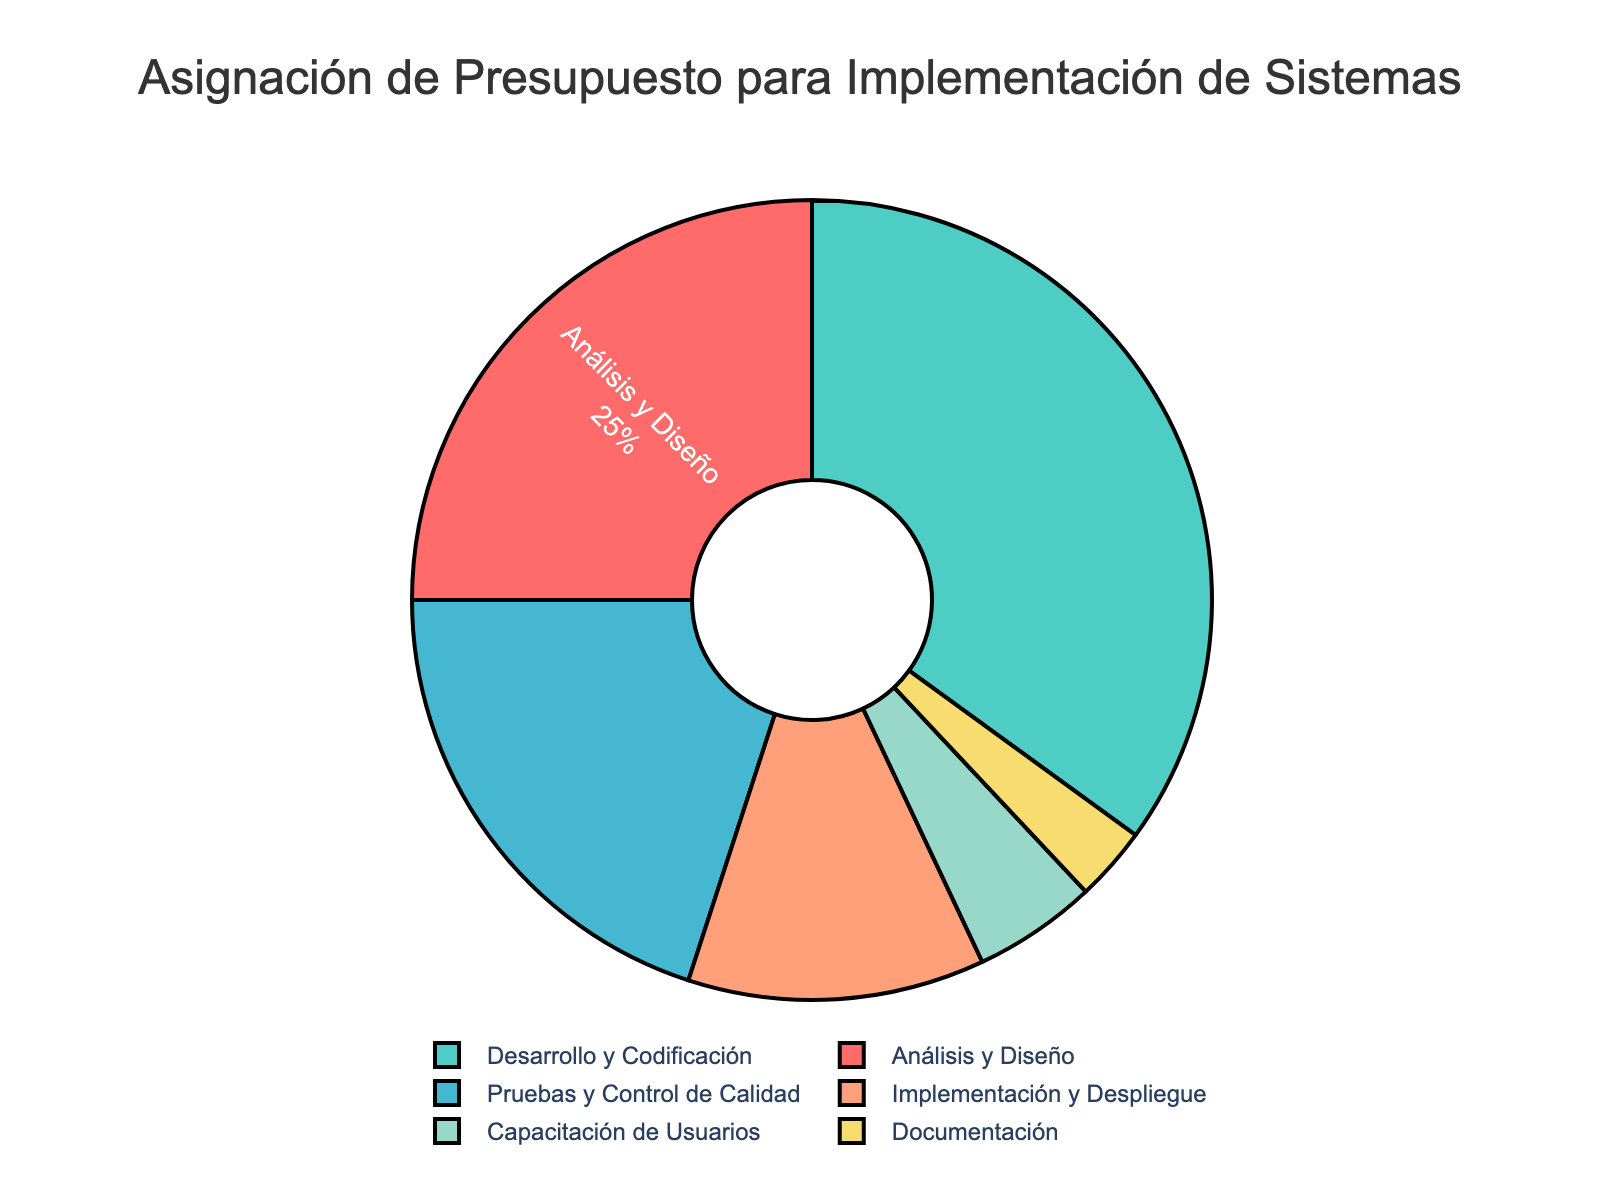What phase has the highest budget allocation? By examining the pie chart, the phase with the largest slice is "Desarrollo y Codificación" which indicates the highest budget allocation.
Answer: Desarrollo y Codificación Which phase has the smallest budget allocation? The smallest slice in the pie chart corresponds to the "Documentación" phase.
Answer: Documentación What's the combined budget allocation for "Pruebas y Control de Calidad" and "Implementación y Despliegue"? Add the percentages of "Pruebas y Control de Calidad" (20%) and "Implementación y Despliegue" (12%). 20 + 12 = 32%
Answer: 32% How much more budget allocation does "Desarrollo y Codificación" have compared to "Análisis y Diseño"? "Desarrollo y Codificación" has 35% and "Análisis y Diseño" has 25%. Subtracting 25 from 35 gives 10%.
Answer: 10% What is the percentage difference between "Capacitación de Usuarios" and "Documentación"? "Capacitación de Usuarios" is 5% while "Documentación" is 3%. The difference is calculated as 5 - 3 = 2%.
Answer: 2% How many phases have a budget allocation higher than 10%? By inspecting the pie chart, the phases with more than 10% allocations are "Análisis y Diseño," "Desarrollo y Codificación," "Pruebas y Control de Calidad," and "Implementación y Despliegue". There are 4 such phases.
Answer: 4 Which two phases together account for exactly 30% of the budget? "Análisis y Diseño" and "Pruebas y Control de Calidad" together have 25% + 20% = 45%, which does not equal 30%. "Implementación y Despliegue" and "Capacitación de Usuarios" together have 12% + 5% = 17%, not 30%. The correct combination is "Pruebas y Control de Calidad" and "Capacitación de Usuarios" with total of 20% + 5% = 25%. There seems to be no pair that sums to exactly 30% based on the data.
Answer: None 